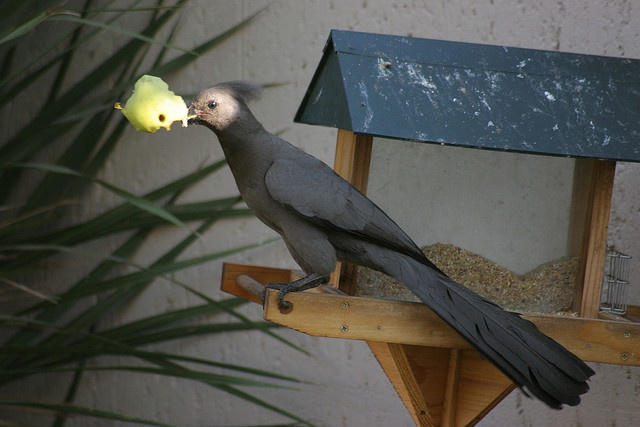Describe the objects in this image and their specific colors. I can see bird in black and gray tones and apple in black, khaki, beige, and olive tones in this image. 